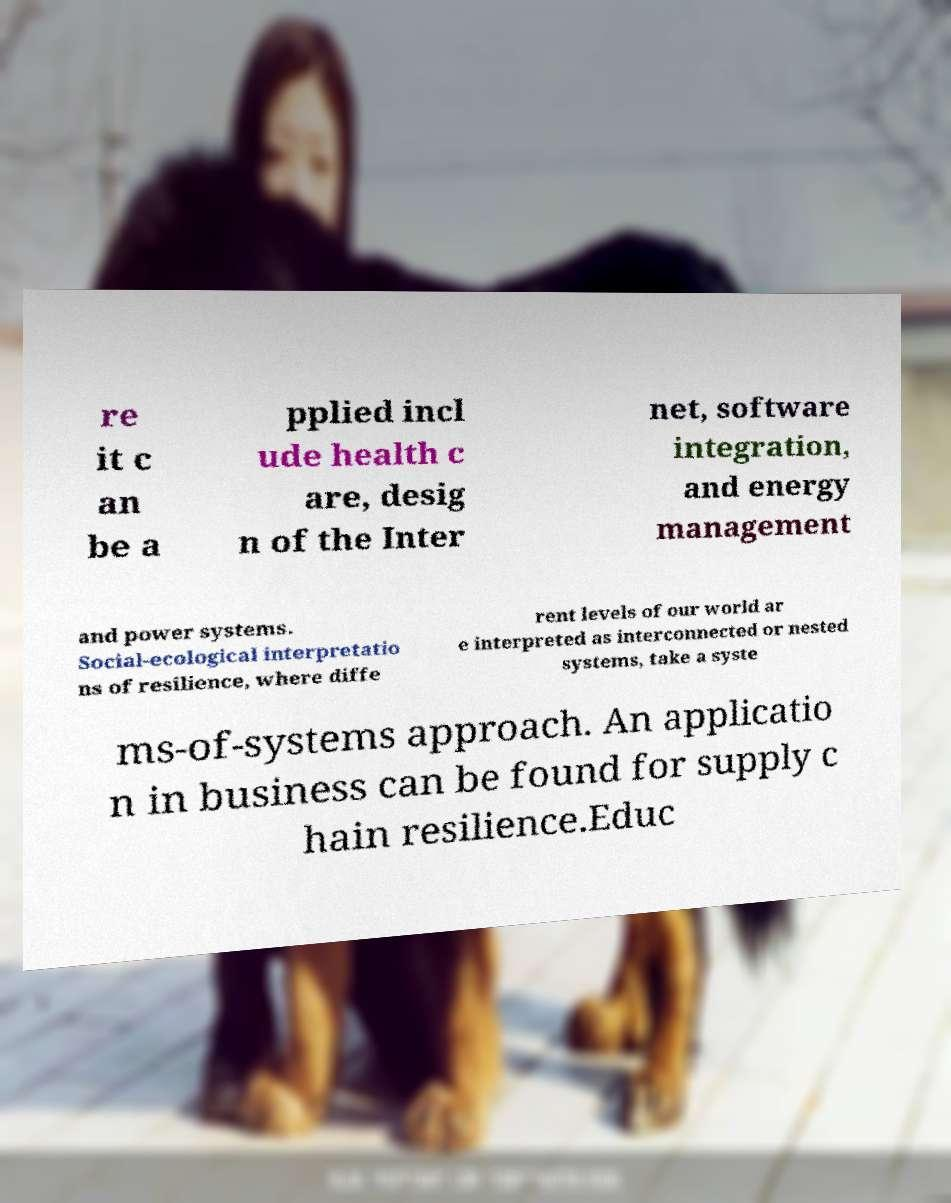For documentation purposes, I need the text within this image transcribed. Could you provide that? re it c an be a pplied incl ude health c are, desig n of the Inter net, software integration, and energy management and power systems. Social-ecological interpretatio ns of resilience, where diffe rent levels of our world ar e interpreted as interconnected or nested systems, take a syste ms-of-systems approach. An applicatio n in business can be found for supply c hain resilience.Educ 